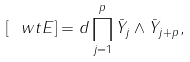<formula> <loc_0><loc_0><loc_500><loc_500>[ \ w t { E } ] = d \prod _ { j = 1 } ^ { p } \bar { Y } _ { j } \wedge \bar { Y } _ { j + p } ,</formula> 